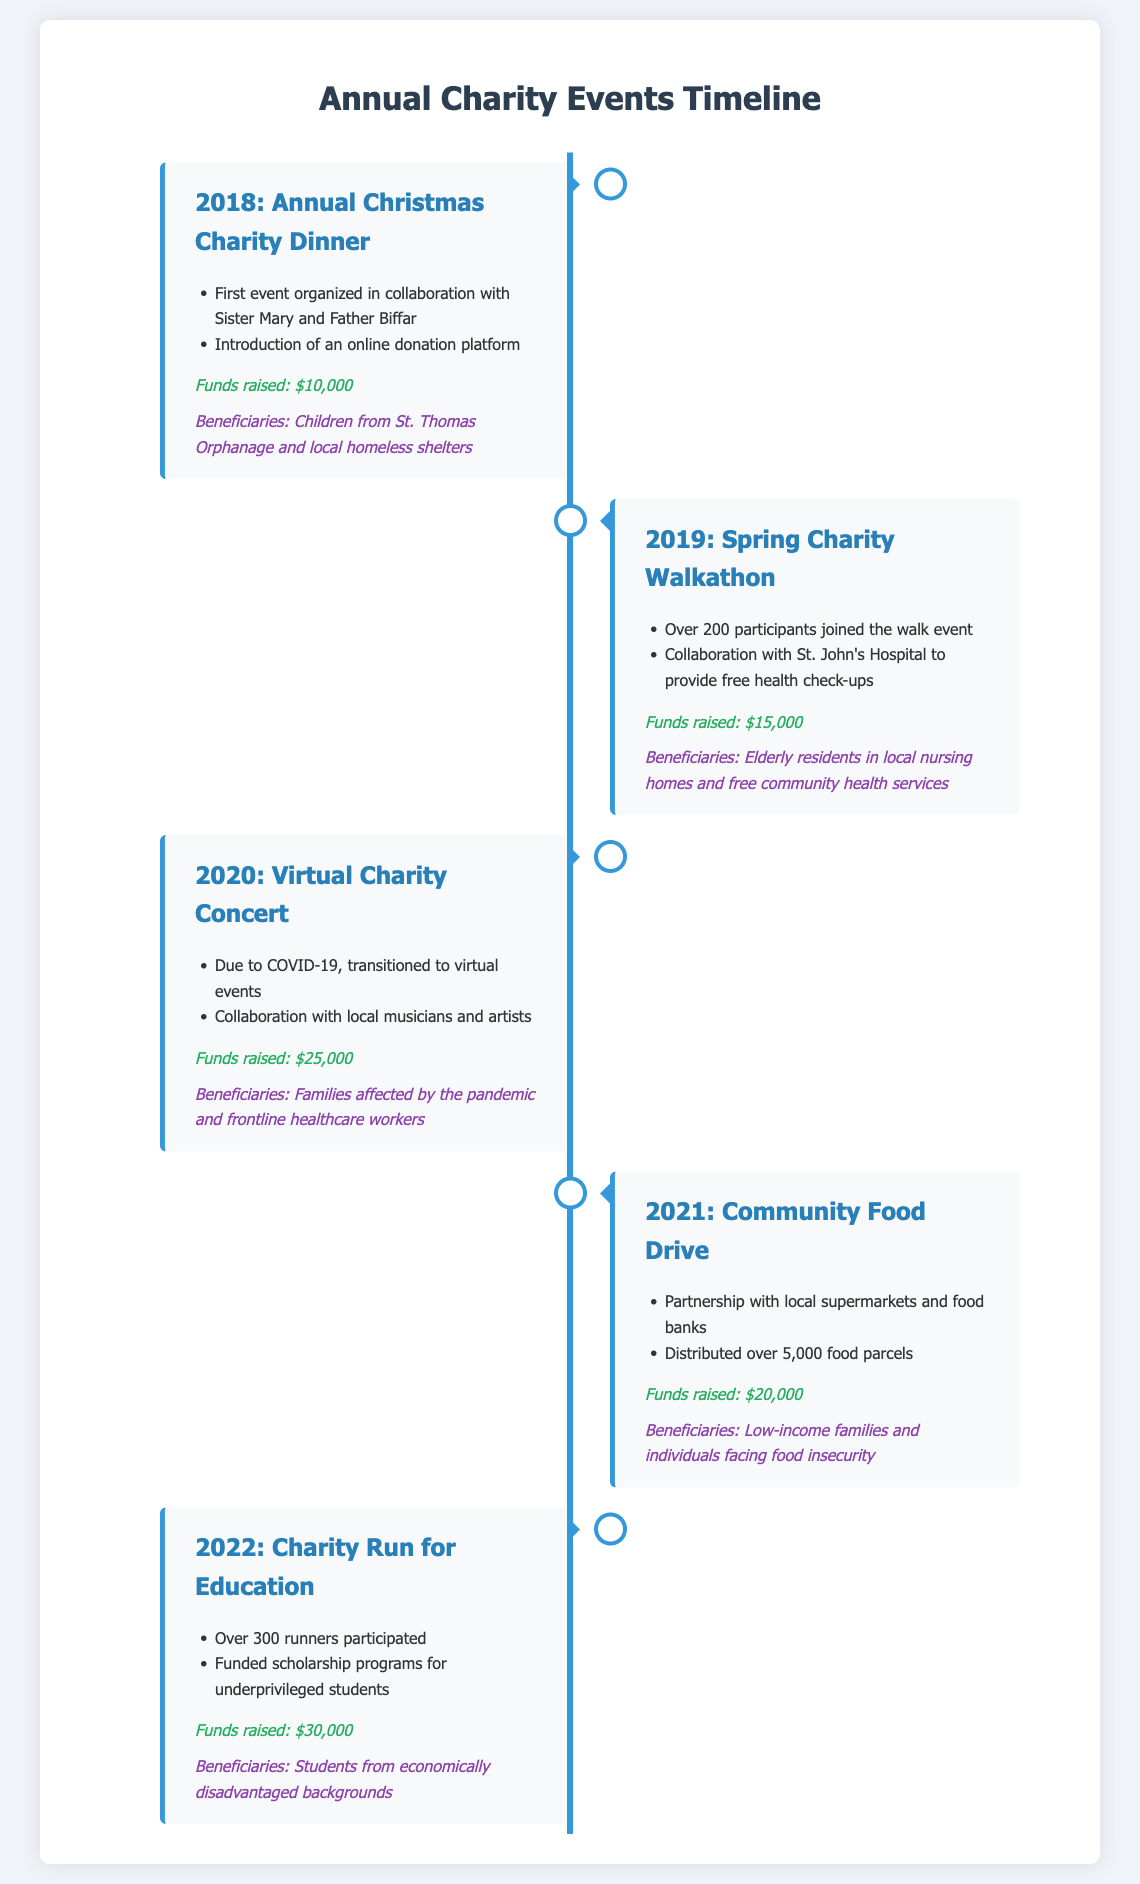What was the first charity event held? The first charity event held was the Annual Christmas Charity Dinner in 2018.
Answer: Annual Christmas Charity Dinner How much money was raised in 2020? The funds raised in 2020 during the Virtual Charity Concert totaled $25,000.
Answer: $25,000 Which charity event supported students? The charity event that supported students was the Charity Run for Education in 2022.
Answer: Charity Run for Education How many food parcels were distributed in 2021? Over 5,000 food parcels were distributed during the Community Food Drive in 2021.
Answer: Over 5,000 What was the funds raised in 2019? The funds raised in 2019 was $15,000 from the Spring Charity Walkathon.
Answer: $15,000 What significant change occurred in 2020? In 2020, the events transitioned to virtual due to COVID-19.
Answer: Transitioned to virtual Which beneficiaries were supported in 2018? The beneficiaries supported in 2018 included children from St. Thomas Orphanage and local homeless shelters.
Answer: Children from St. Thomas Orphanage and local homeless shelters What type of event was held in 2019? The event held in 2019 was a Spring Charity Walkathon.
Answer: Spring Charity Walkathon How many participants took part in the 2022 event? Over 300 runners participated in the Charity Run for Education in 2022.
Answer: Over 300 runners 